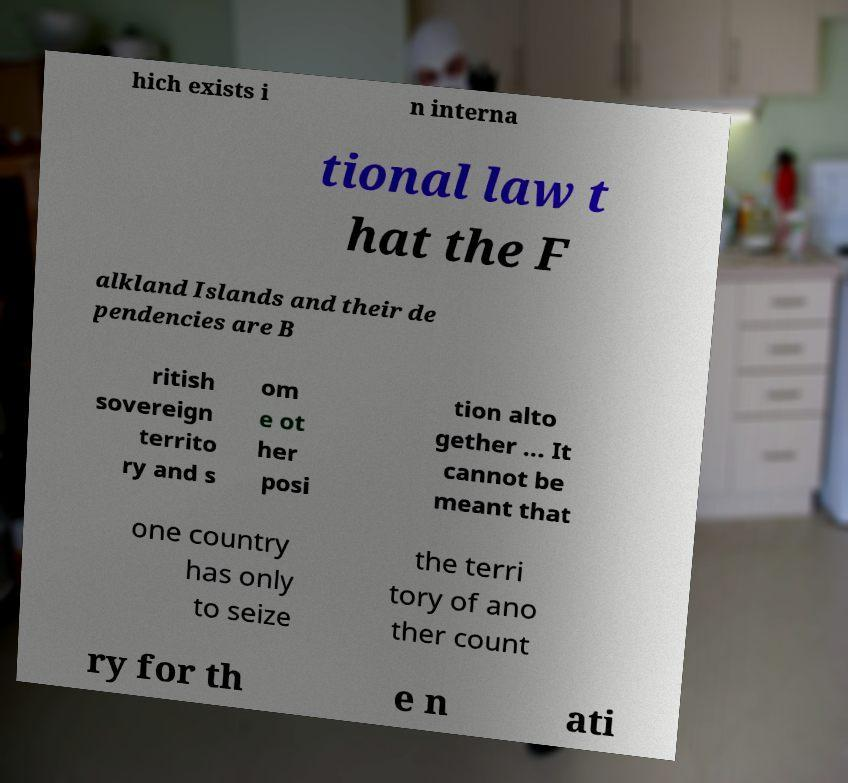Please read and relay the text visible in this image. What does it say? hich exists i n interna tional law t hat the F alkland Islands and their de pendencies are B ritish sovereign territo ry and s om e ot her posi tion alto gether ... It cannot be meant that one country has only to seize the terri tory of ano ther count ry for th e n ati 